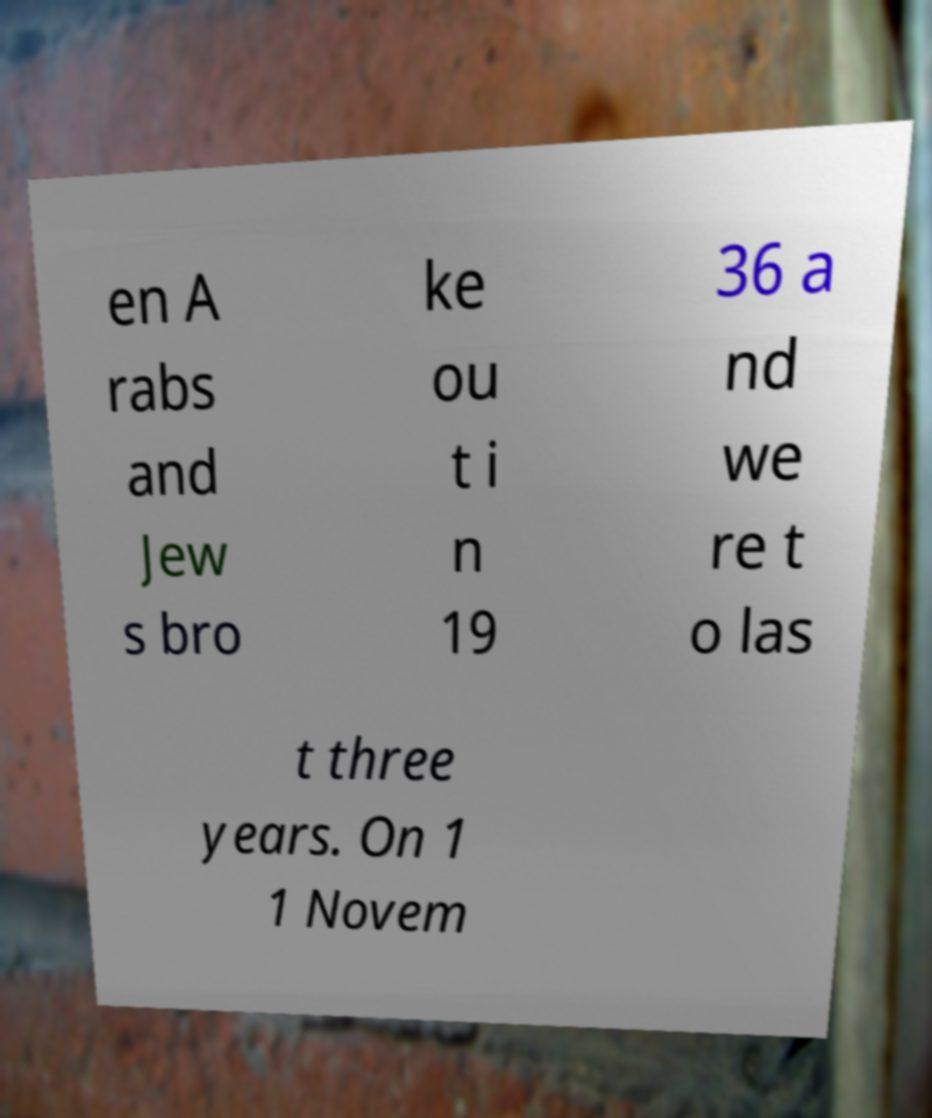What messages or text are displayed in this image? I need them in a readable, typed format. en A rabs and Jew s bro ke ou t i n 19 36 a nd we re t o las t three years. On 1 1 Novem 